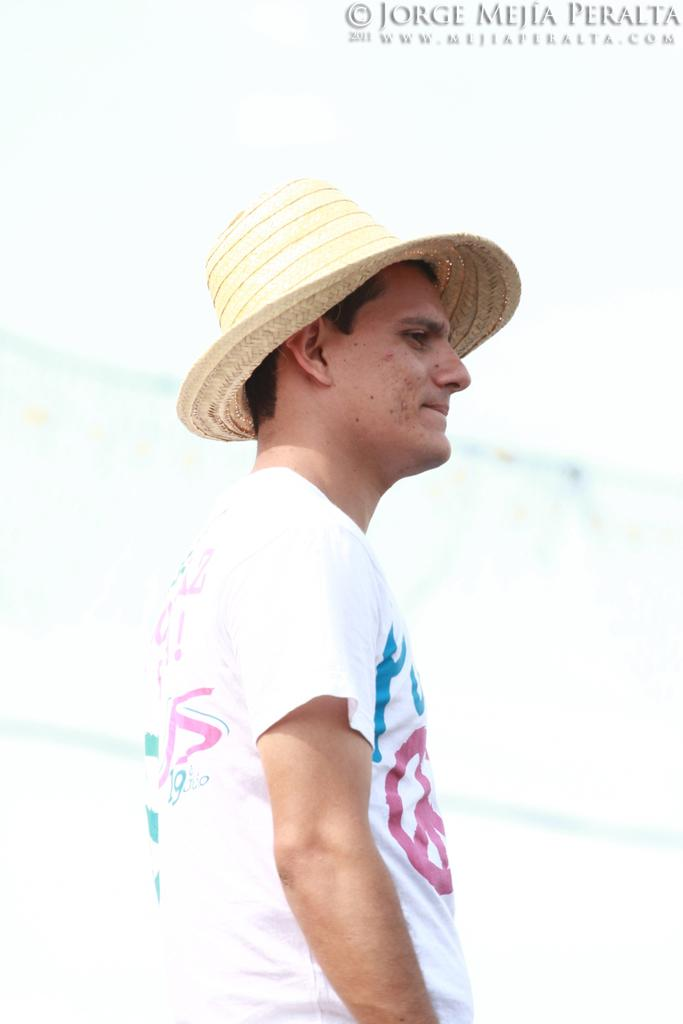Who or what is the main subject in the image? There is a person in the image. What is the person wearing on their head? The person is wearing a hat. Are there any visible marks or features in the image that are not related to the person? Yes, there are watermarks in the top right corner of the image. What type of finger can be seen holding the knife in the image? There is no finger or knife present in the image. 